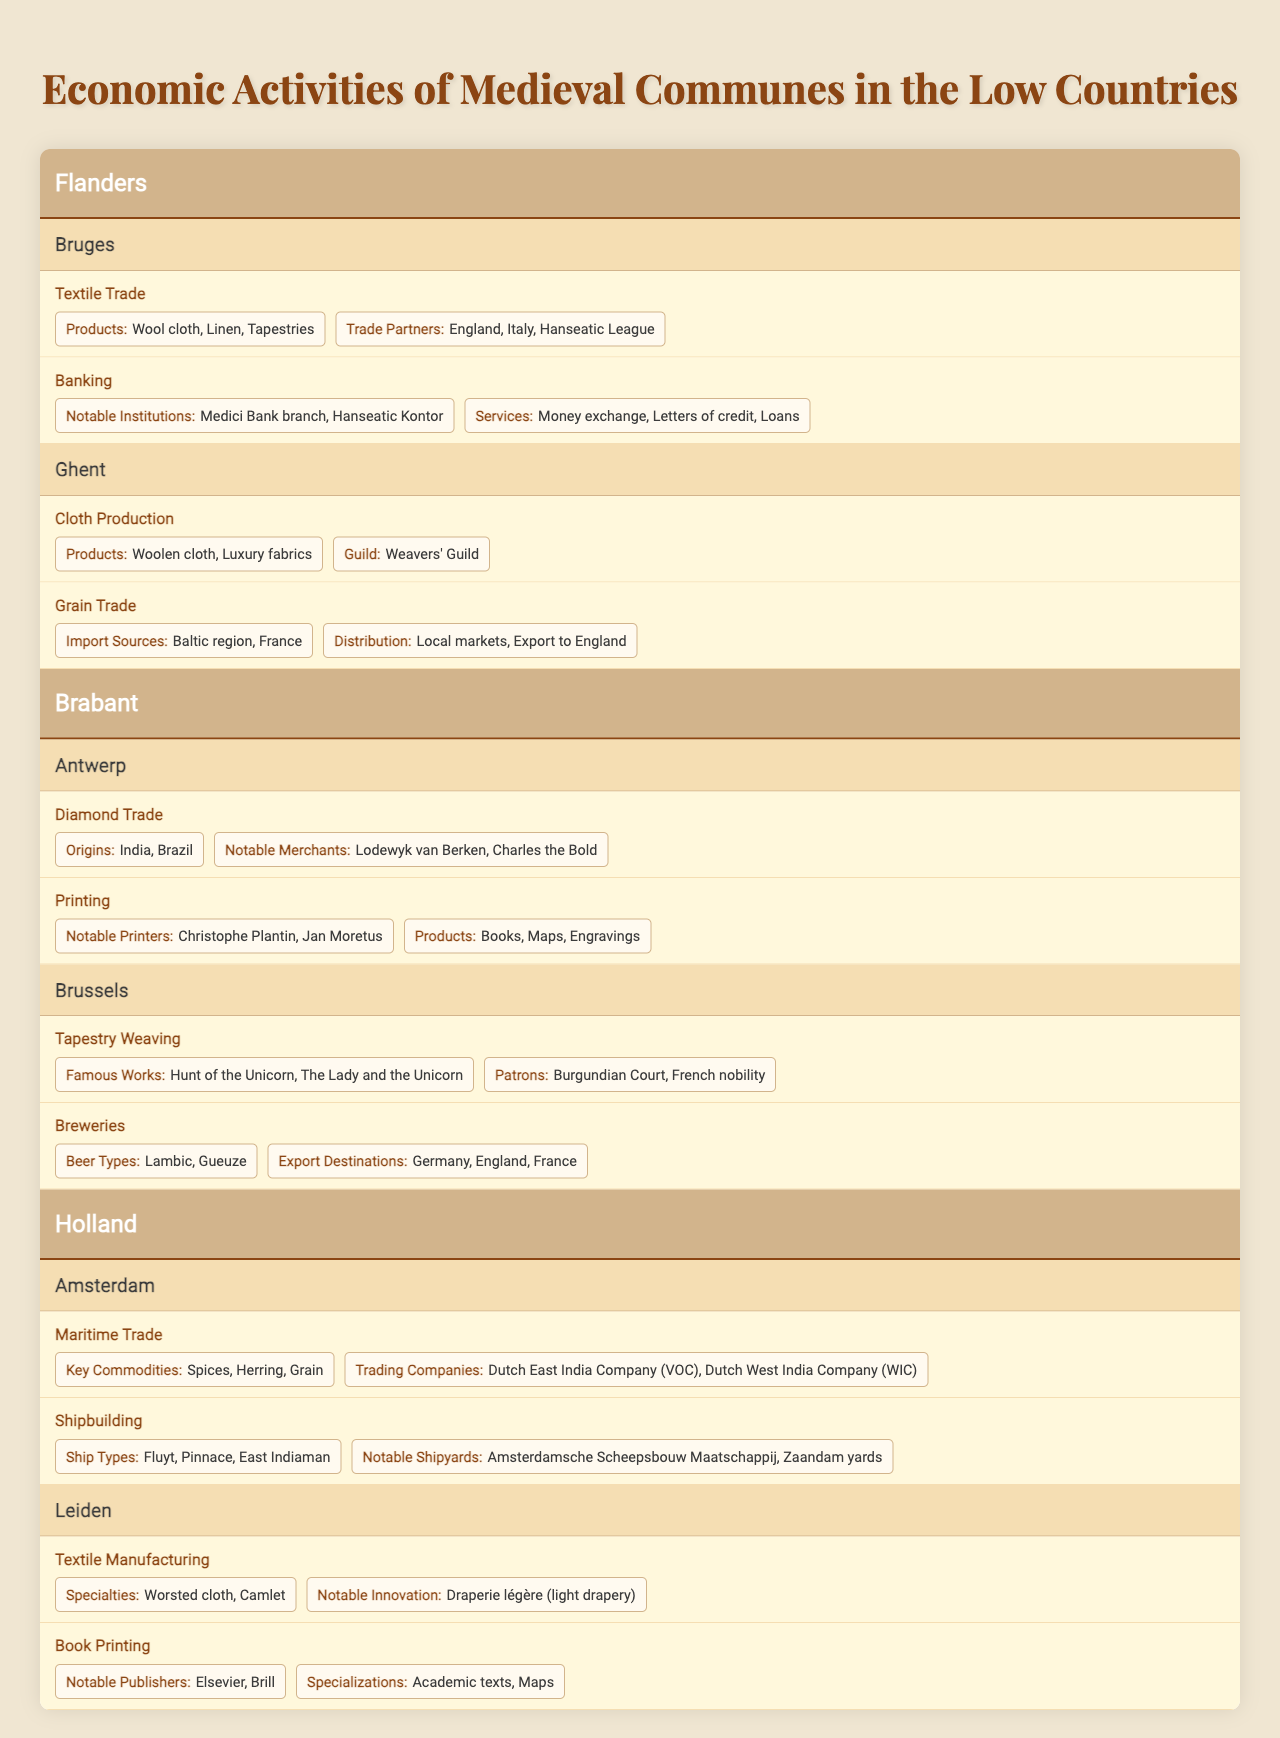What are the main economic activities in Bruges? In the table, Bruges is listed under the Flanders region. It has two main economic activities: Textile Trade and Banking.
Answer: Textile Trade and Banking Which commune is known for its grain trade? Looking at the communes listed, Ghent has grain trade as one of its main economic activities, which involves imports from the Baltic region and France.
Answer: Ghent What products are associated with the diamond trade in Antwerp? The table indicates that the diamond trade in Antwerp is associated with gems sourced from India and Brazil.
Answer: India and Brazil Is Tapestry Weaving a main activity in Brussels? The data shows that Tapestry Weaving is listed as one of the main economic activities in Brussels. Therefore, the statement is true.
Answer: Yes List the notable institutions associated with banking in Bruges. The table provides two notable institutions: Medici Bank branch and Hanseatic Kontor, which are linked to banking activities in Bruges.
Answer: Medici Bank branch, Hanseatic Kontor Which commune has a guild specifically for cloth production? The table reveals that Ghent, with its Weavers' Guild, is the commune associated with cloth production.
Answer: Ghent How does the number of economic activities in Antwerp compare to those in Bruges? Antwerp has two main economic activities (Diamond Trade and Printing), while Bruges also has two (Textile Trade and Banking), hence both communes have an equal number of economic activities.
Answer: Equal What are the key commodities involved in maritime trade at Amsterdam? According to the table, the key commodities involved in Amsterdam's maritime trade include spices, herring, and grain.
Answer: Spices, herring, grain What innovations are notable in the textile manufacturing of Leiden? The data notes that Leiden's textile manufacturing includes the notable innovation of Draperie légère (light drapery).
Answer: Draperie légère Which commune has a historical association with the Burgundian Court in the context of tapestry? The table indicates that Brussels has been associated with the Burgundian Court regarding its tapestry weaving activities.
Answer: Brussels 